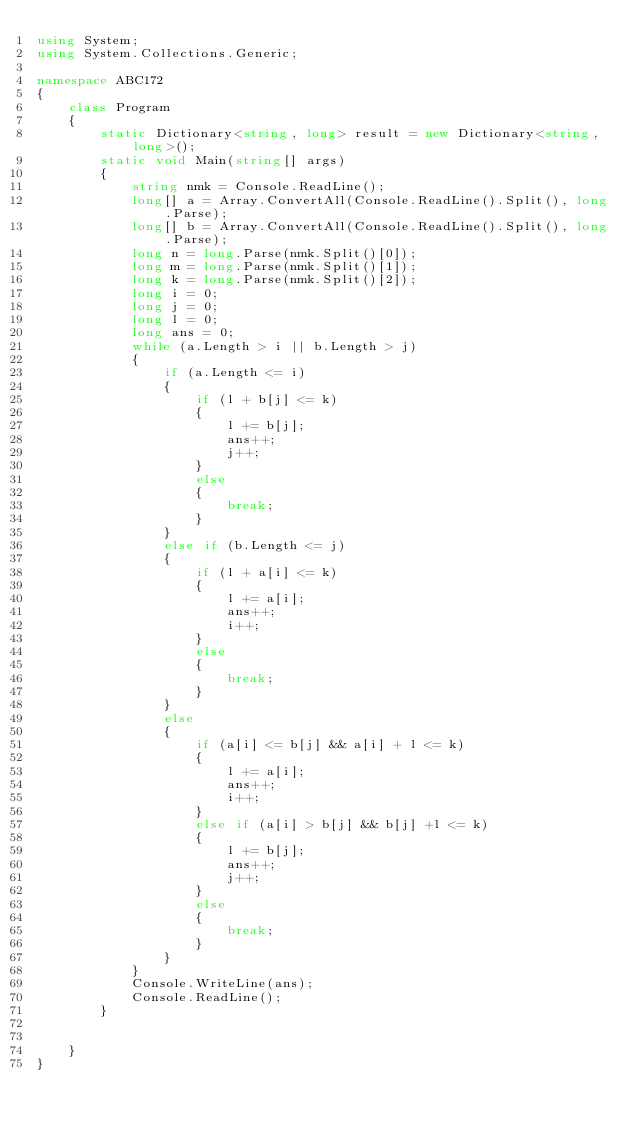<code> <loc_0><loc_0><loc_500><loc_500><_C#_>using System;
using System.Collections.Generic;

namespace ABC172
{
    class Program
    {
        static Dictionary<string, long> result = new Dictionary<string, long>();
        static void Main(string[] args)
        {
            string nmk = Console.ReadLine();
            long[] a = Array.ConvertAll(Console.ReadLine().Split(), long.Parse);
            long[] b = Array.ConvertAll(Console.ReadLine().Split(), long.Parse);
            long n = long.Parse(nmk.Split()[0]);
            long m = long.Parse(nmk.Split()[1]);
            long k = long.Parse(nmk.Split()[2]);
            long i = 0;
            long j = 0;
            long l = 0;
            long ans = 0;
            while (a.Length > i || b.Length > j)
            {
                if (a.Length <= i)
                {
                    if (l + b[j] <= k)
                    {
                        l += b[j];
                        ans++;
                        j++;
                    }
                    else
                    {
                        break;
                    }
                }
                else if (b.Length <= j)
                {
                    if (l + a[i] <= k)
                    {
                        l += a[i];
                        ans++;
                        i++;
                    }
                    else
                    {
                        break;
                    }
                }
                else
                {
                    if (a[i] <= b[j] && a[i] + l <= k)
                    {
                        l += a[i];
                        ans++;
                        i++;
                    }
                    else if (a[i] > b[j] && b[j] +l <= k)
                    {
                        l += b[j];
                        ans++;
                        j++;
                    }
                    else
                    {
                        break;
                    }
                }
            }
            Console.WriteLine(ans);
            Console.ReadLine();
        }


    }
}
</code> 